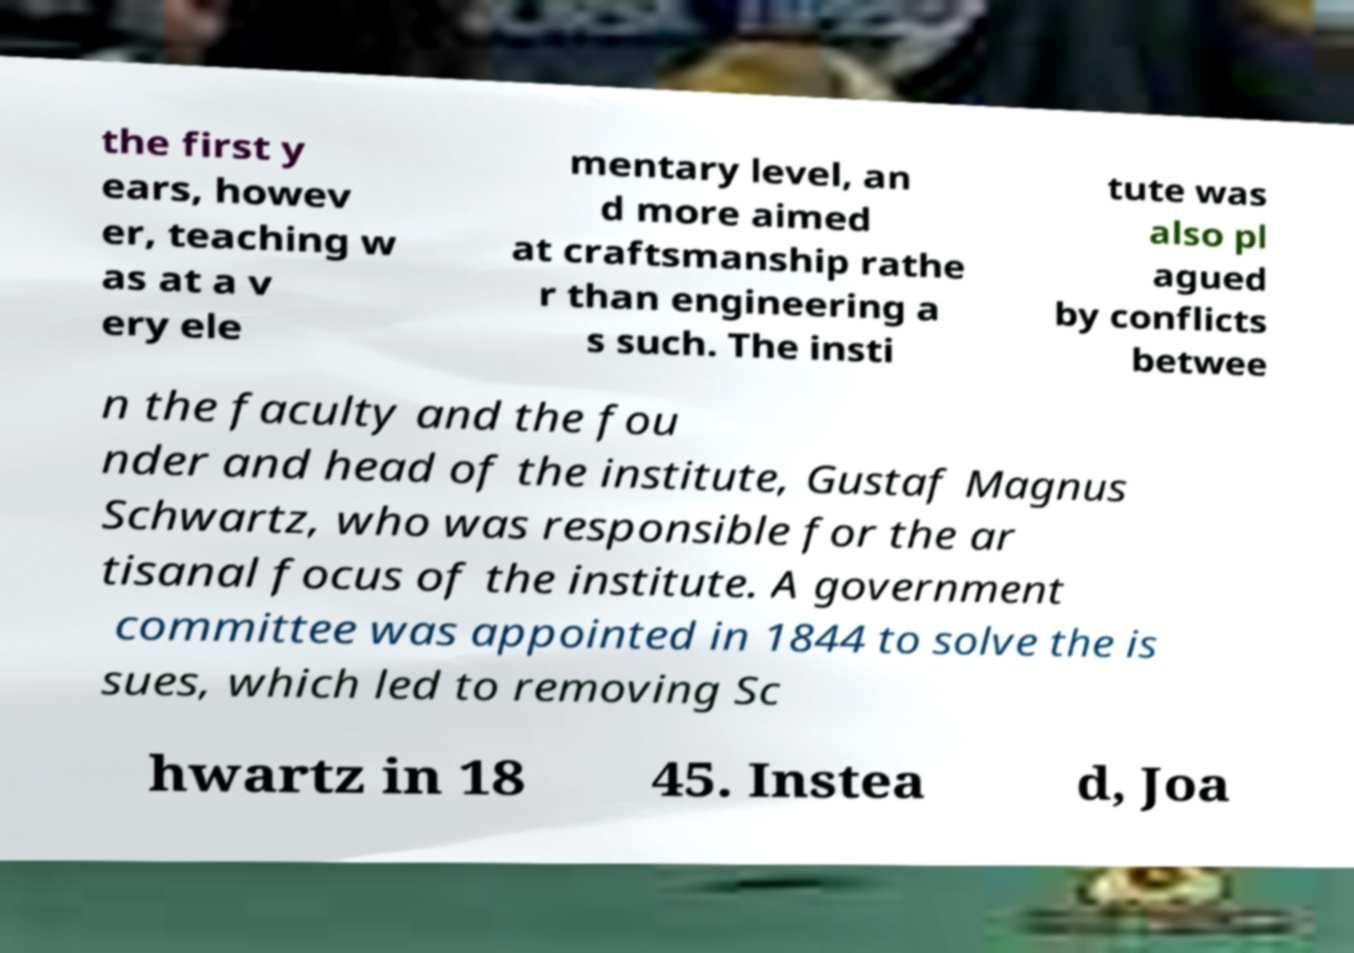I need the written content from this picture converted into text. Can you do that? the first y ears, howev er, teaching w as at a v ery ele mentary level, an d more aimed at craftsmanship rathe r than engineering a s such. The insti tute was also pl agued by conflicts betwee n the faculty and the fou nder and head of the institute, Gustaf Magnus Schwartz, who was responsible for the ar tisanal focus of the institute. A government committee was appointed in 1844 to solve the is sues, which led to removing Sc hwartz in 18 45. Instea d, Joa 